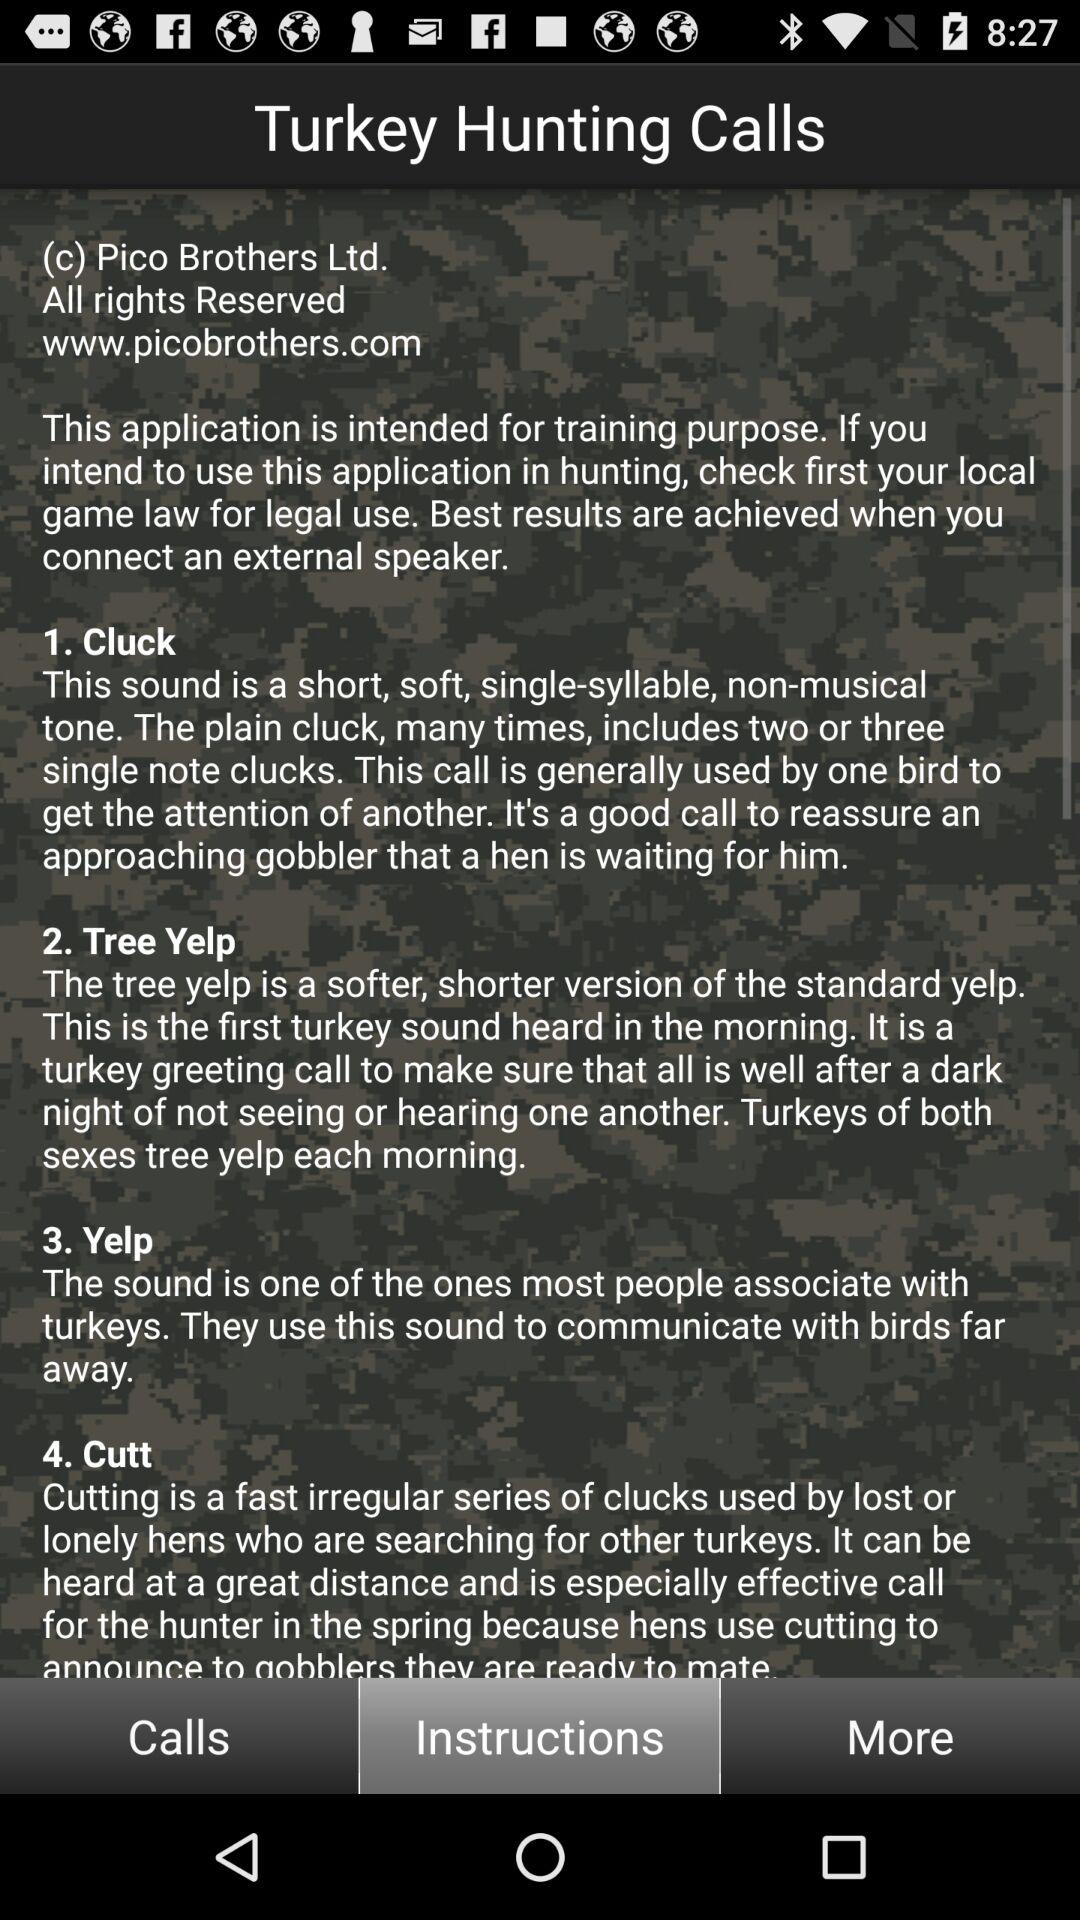What tab is currently selected? The selected tab is "Instructions". 